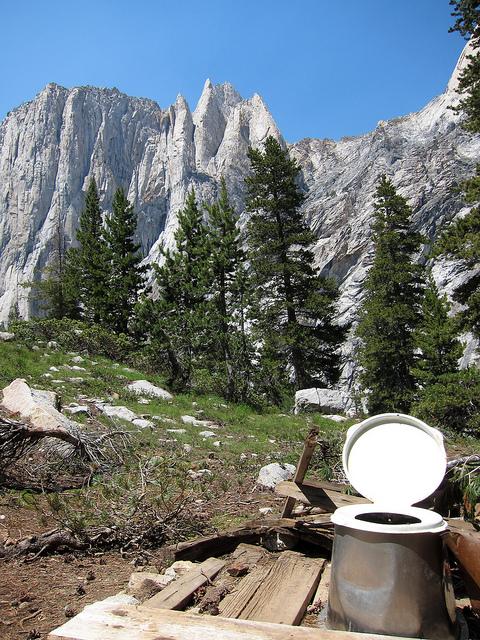What kind of trees are these?
Keep it brief. Pine. Is this a beautiful landscape?
Concise answer only. Yes. What is the weather like?
Answer briefly. Sunny. Is that a toilet to the right?
Write a very short answer. Yes. 